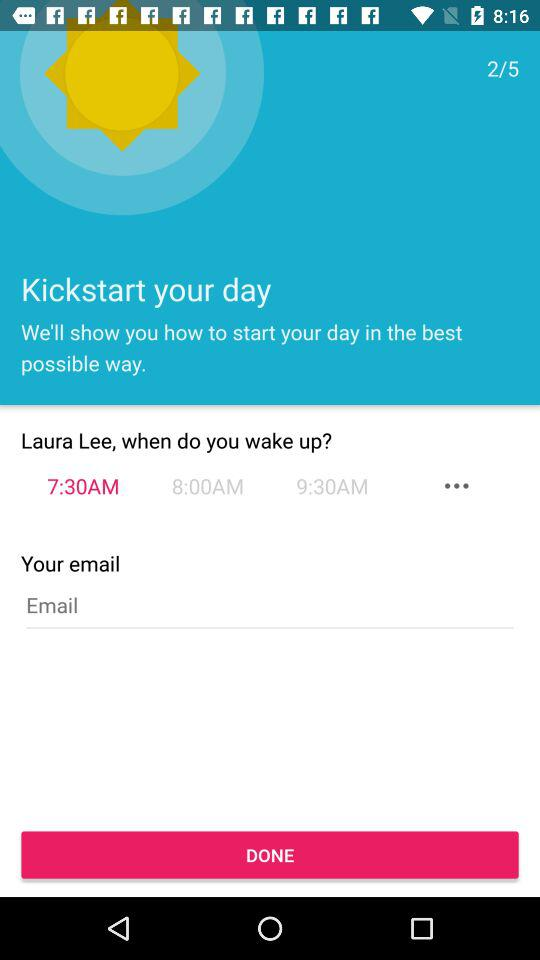At which step am I? You are at second step. 